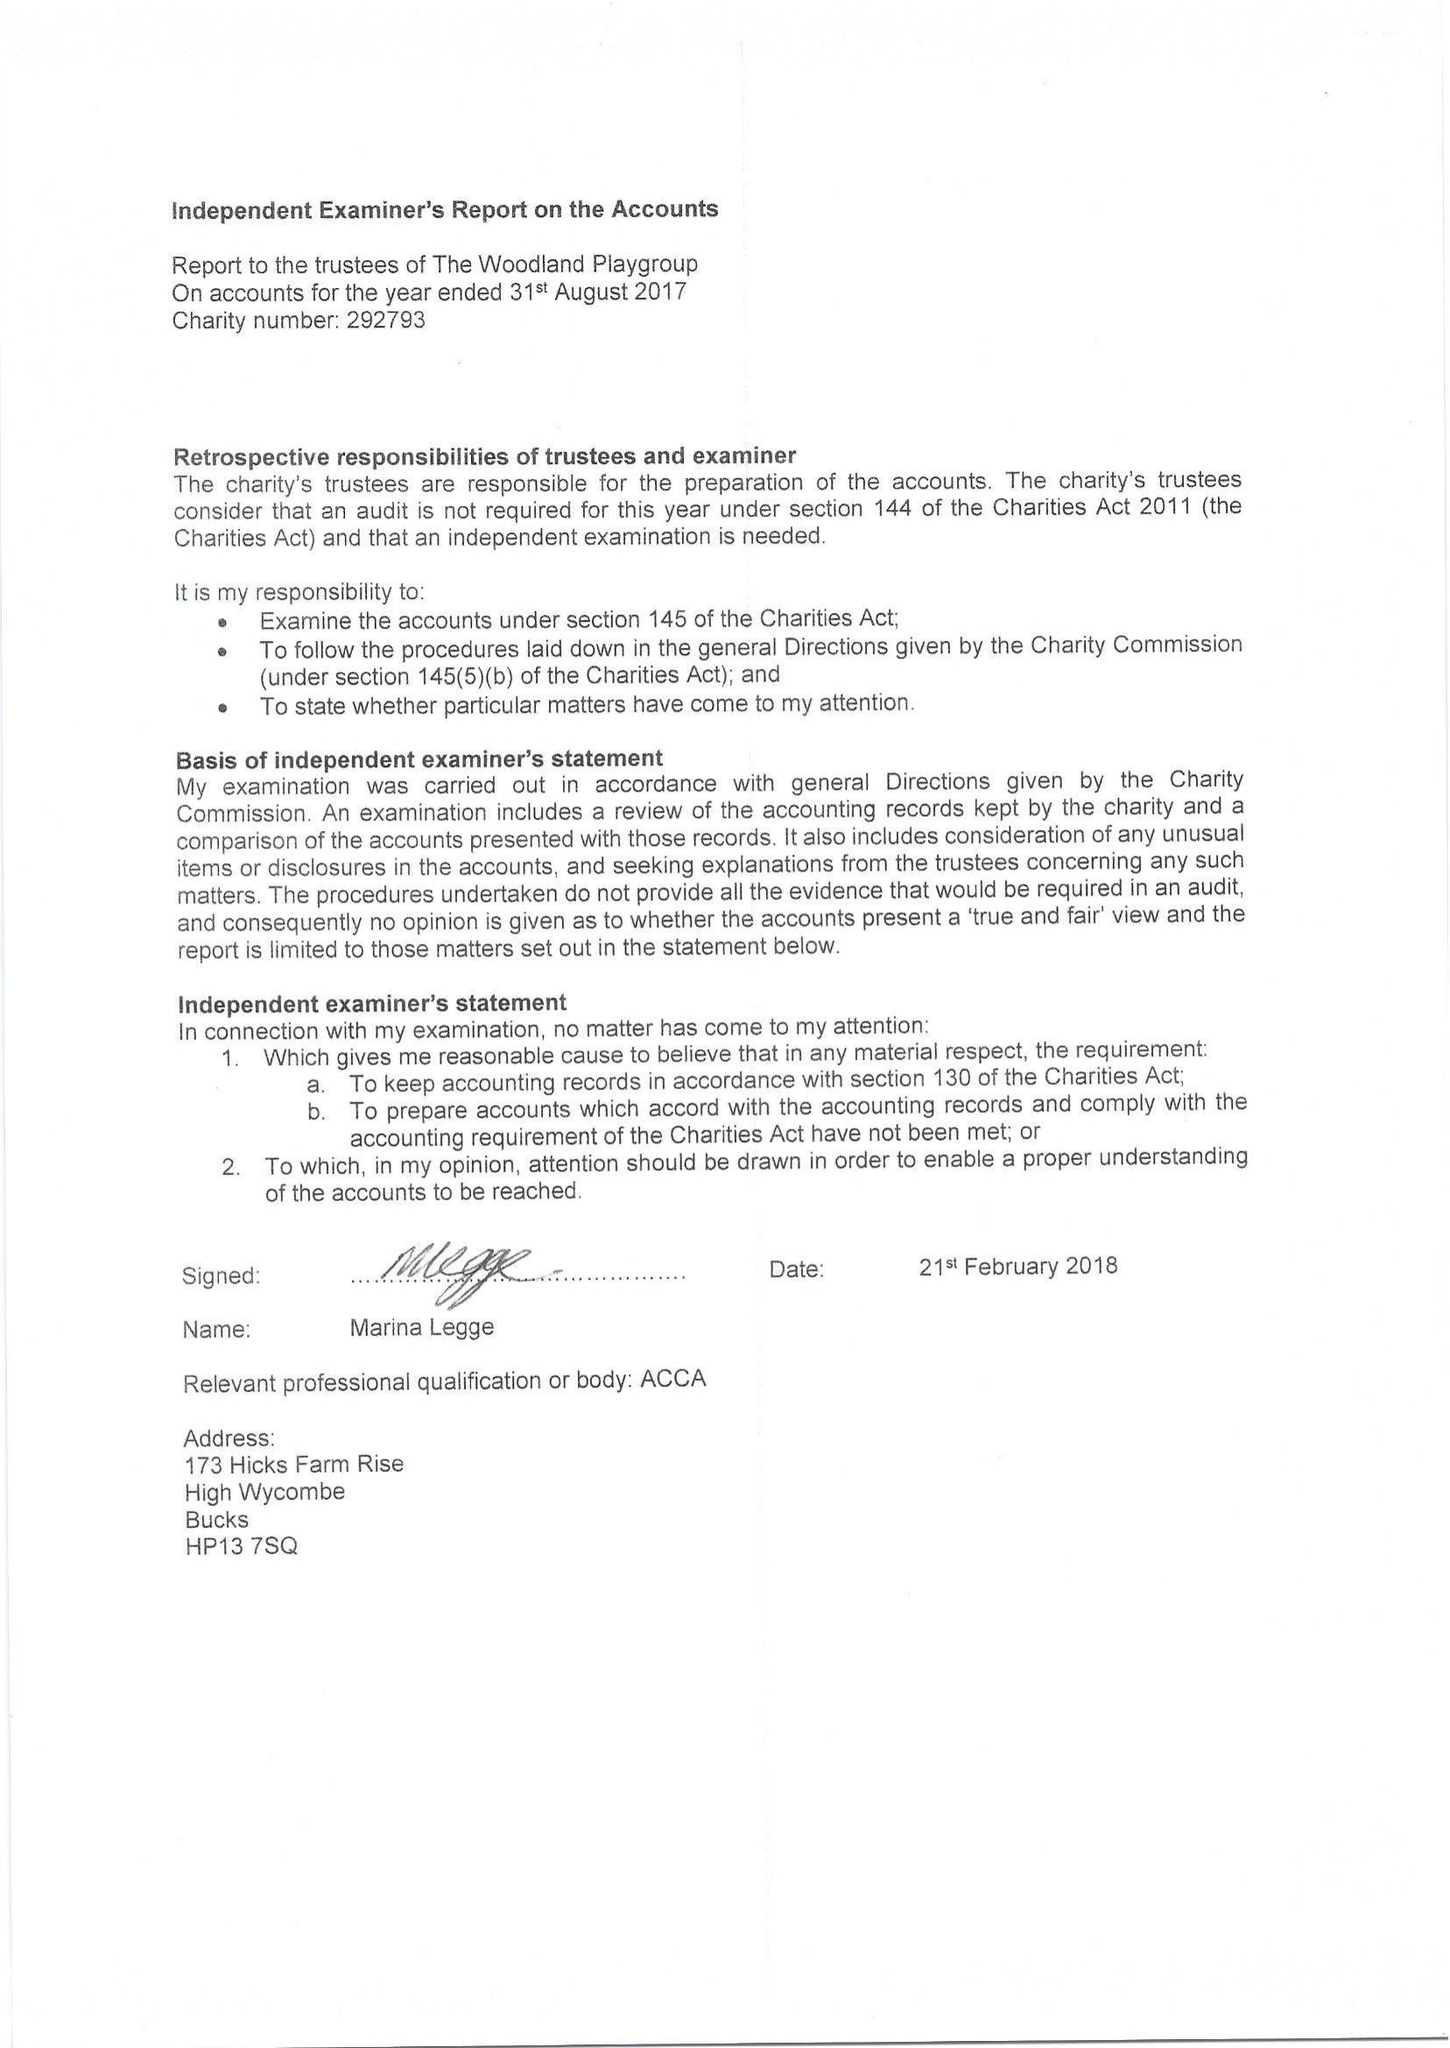What is the value for the charity_number?
Answer the question using a single word or phrase. 292793 